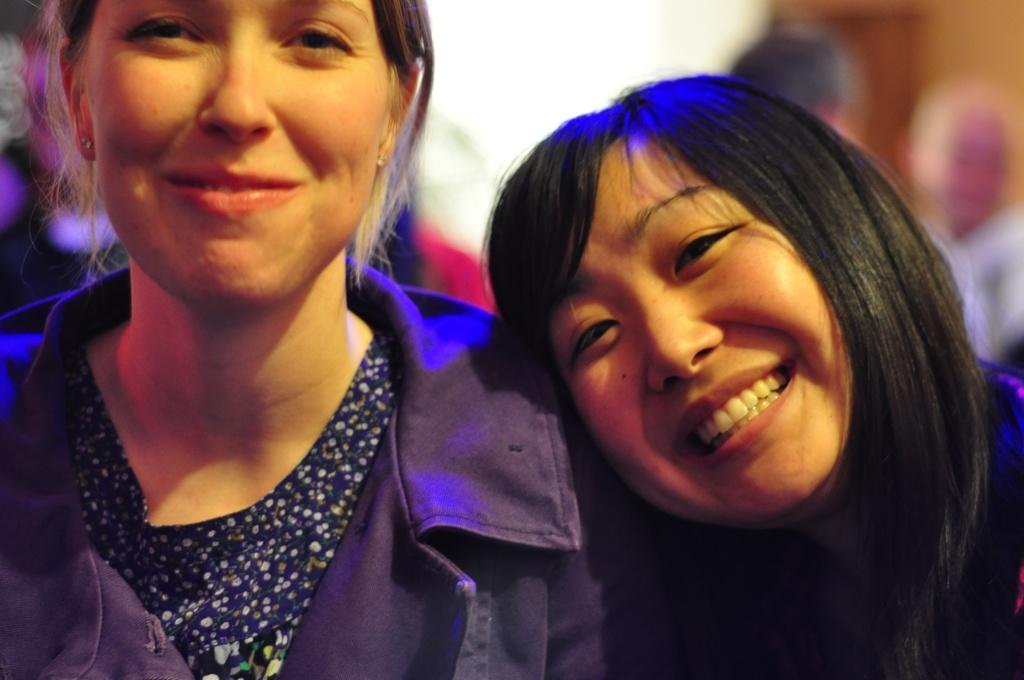How many people are in the image? There are persons in the image. What expression do the persons have? The persons are smiling. Can you describe the background of the image? The background of the image is blurry. How many giants can be seen playing on the playground in the image? There are no giants or playground present in the image. 